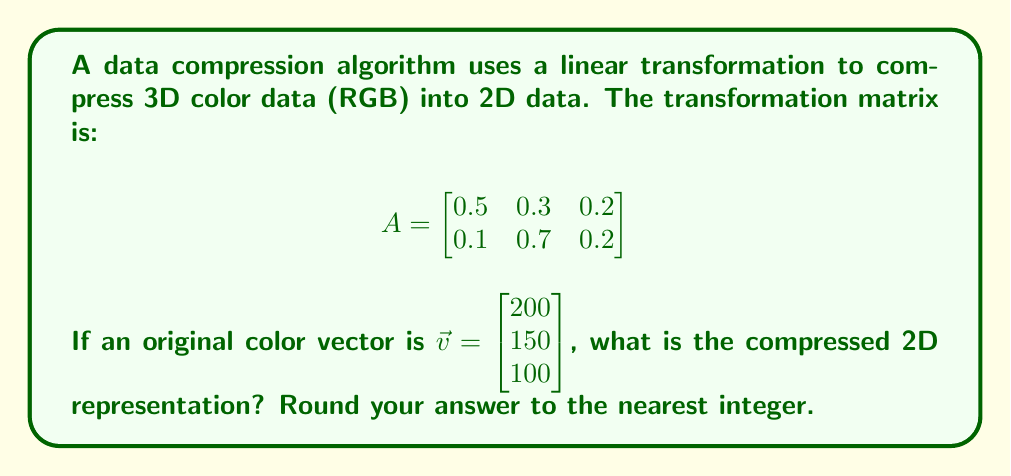Can you answer this question? To find the compressed 2D representation, we need to multiply the transformation matrix $A$ by the original color vector $\vec{v}$. Let's break this down step-by-step:

1) The matrix multiplication is given by:

   $$A\vec{v} = \begin{bmatrix}
   0.5 & 0.3 & 0.2 \\
   0.1 & 0.7 & 0.2
   \end{bmatrix} \begin{bmatrix} 200 \\ 150 \\ 100 \end{bmatrix}$$

2) Let's calculate each component of the resulting 2D vector:

   For the first component:
   $$(0.5 \times 200) + (0.3 \times 150) + (0.2 \times 100) = 100 + 45 + 20 = 165$$

   For the second component:
   $$(0.1 \times 200) + (0.7 \times 150) + (0.2 \times 100) = 20 + 105 + 20 = 145$$

3) Therefore, the resulting 2D vector before rounding is:

   $$\begin{bmatrix} 165 \\ 145 \end{bmatrix}$$

4) Rounding to the nearest integer:

   $$\begin{bmatrix} 165 \\ 145 \end{bmatrix}$$

   (Both values are already whole numbers, so no rounding is necessary in this case)
Answer: $\begin{bmatrix} 165 \\ 145 \end{bmatrix}$ 